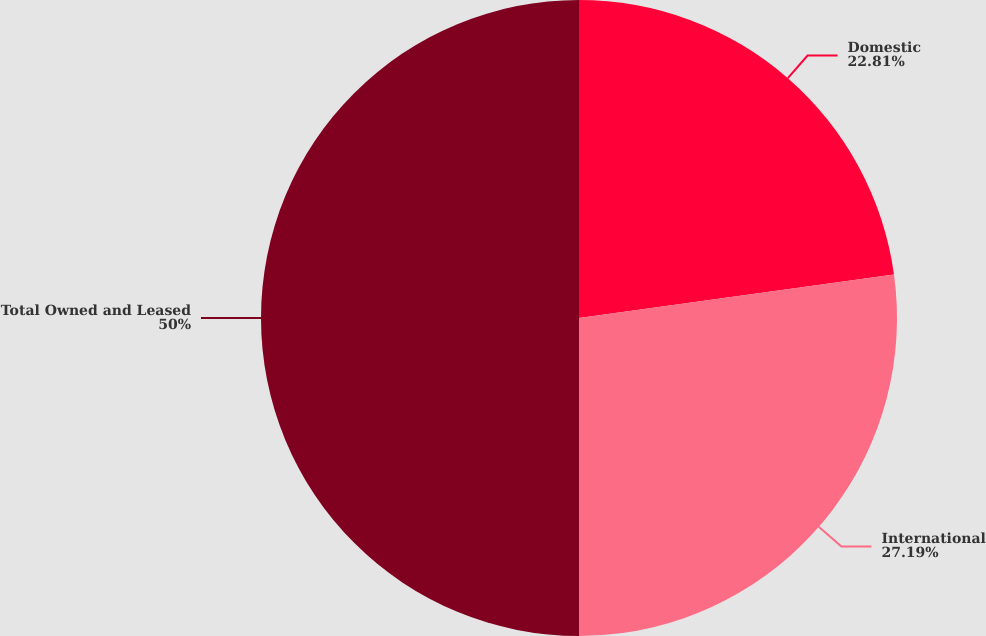Convert chart to OTSL. <chart><loc_0><loc_0><loc_500><loc_500><pie_chart><fcel>Domestic<fcel>International<fcel>Total Owned and Leased<nl><fcel>22.81%<fcel>27.19%<fcel>50.0%<nl></chart> 